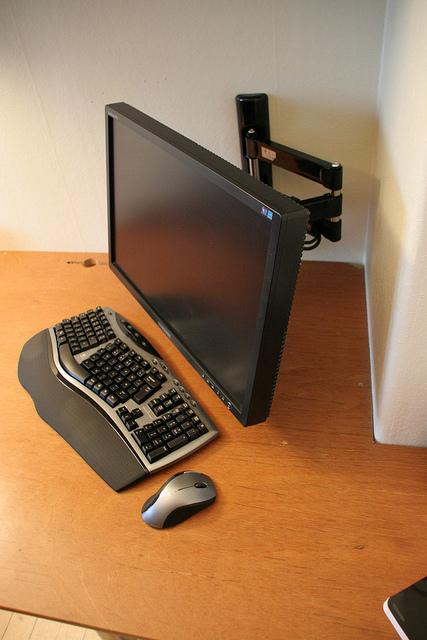What is the mouse next to? Please explain your reasoning. keyboard. The mouse is beside the keyboard on the desk. 